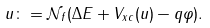<formula> <loc_0><loc_0><loc_500><loc_500>u \colon = \mathcal { N } _ { f } ( \Delta E + V _ { x c } ( u ) - q \varphi ) .</formula> 